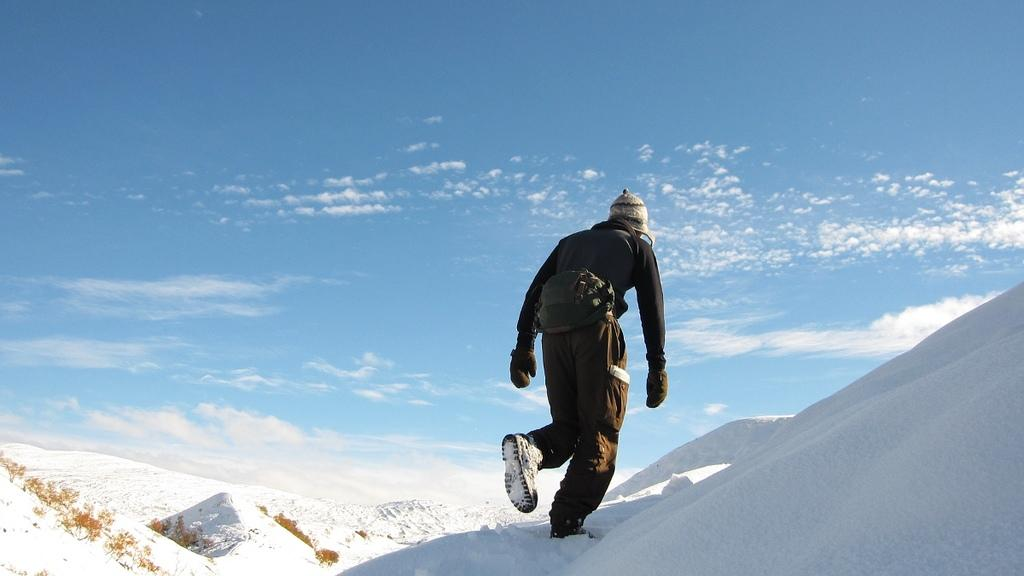What is the person in the image doing? The person is walking in the image. What is the surface the person is walking on? The person is walking on snow. What is the person wearing? The person is wearing a black dress. What can be seen in the background of the image? The sky is visible in the background of the image. What colors are present in the sky? The sky has blue and white colors. What type of calculator is the person holding in the image? There is no calculator present in the image; the person is walking on snow while wearing a black dress. 